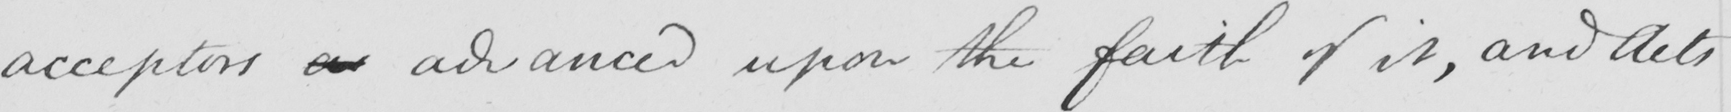What is written in this line of handwriting? acceptors as advanced upon the faith of it , and Acts 